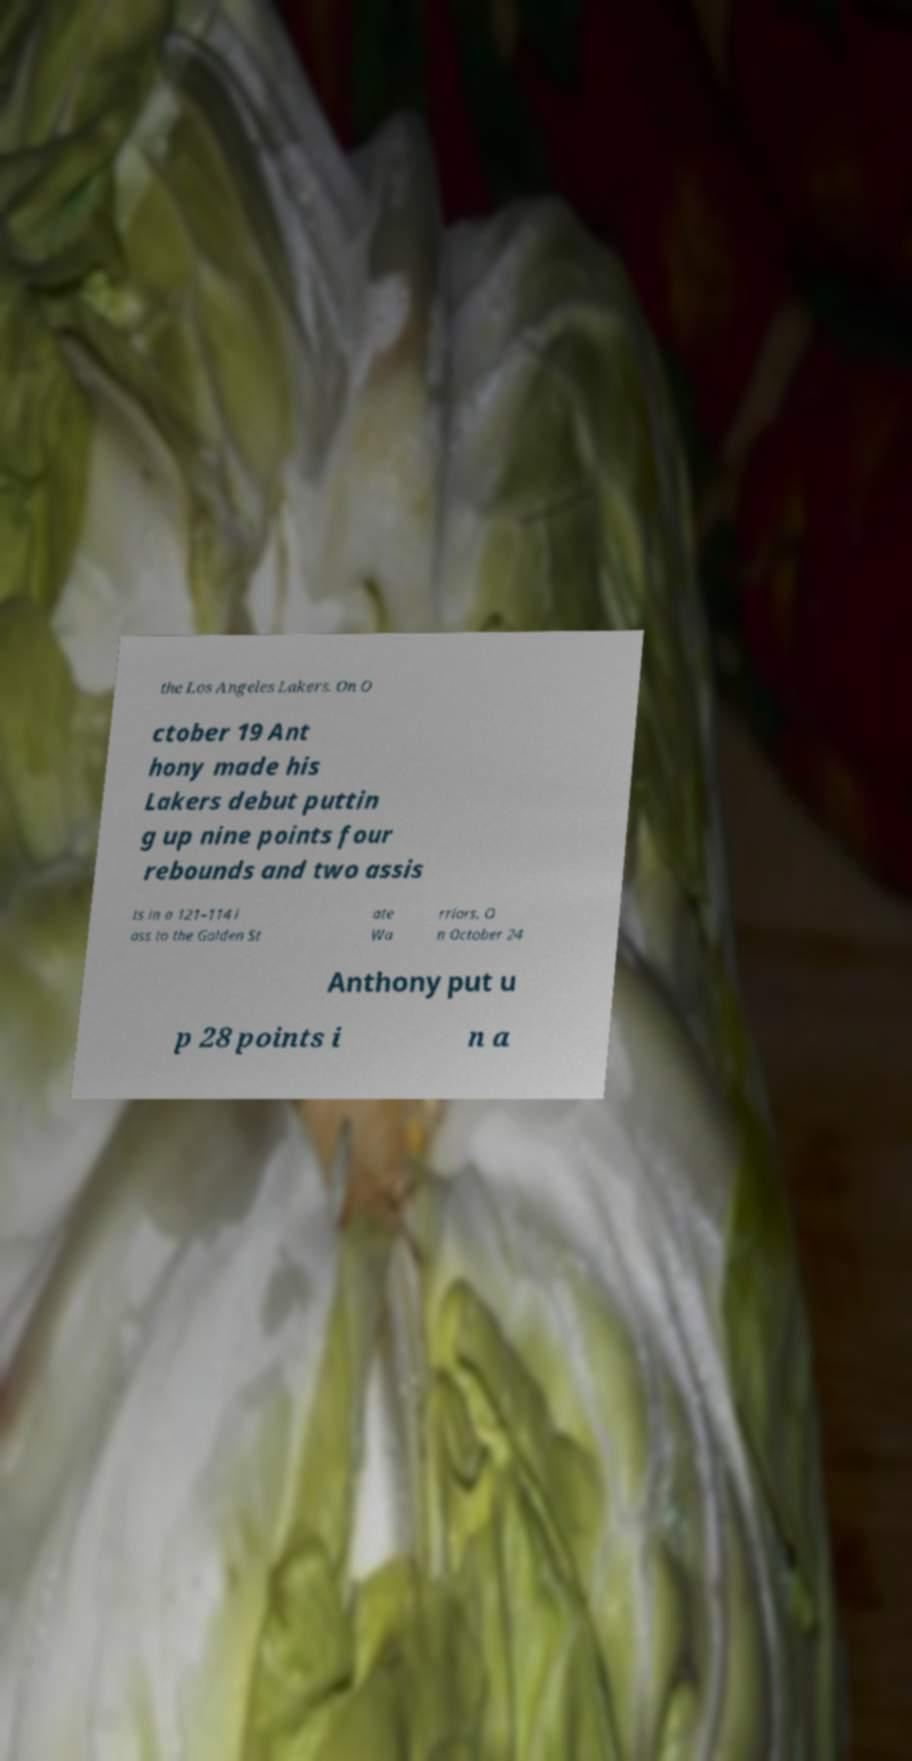Can you read and provide the text displayed in the image?This photo seems to have some interesting text. Can you extract and type it out for me? the Los Angeles Lakers. On O ctober 19 Ant hony made his Lakers debut puttin g up nine points four rebounds and two assis ts in a 121–114 l oss to the Golden St ate Wa rriors. O n October 24 Anthony put u p 28 points i n a 